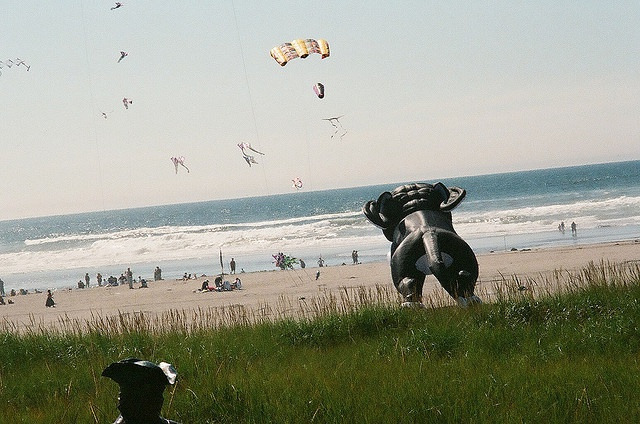Describe the objects in this image and their specific colors. I can see people in lightgray, darkgray, gray, and tan tones, kite in lightgray, ivory, tan, and darkgray tones, kite in lightgray, darkgray, and gray tones, kite in lightgray, darkgray, and gray tones, and kite in lightgray, darkgray, and gray tones in this image. 